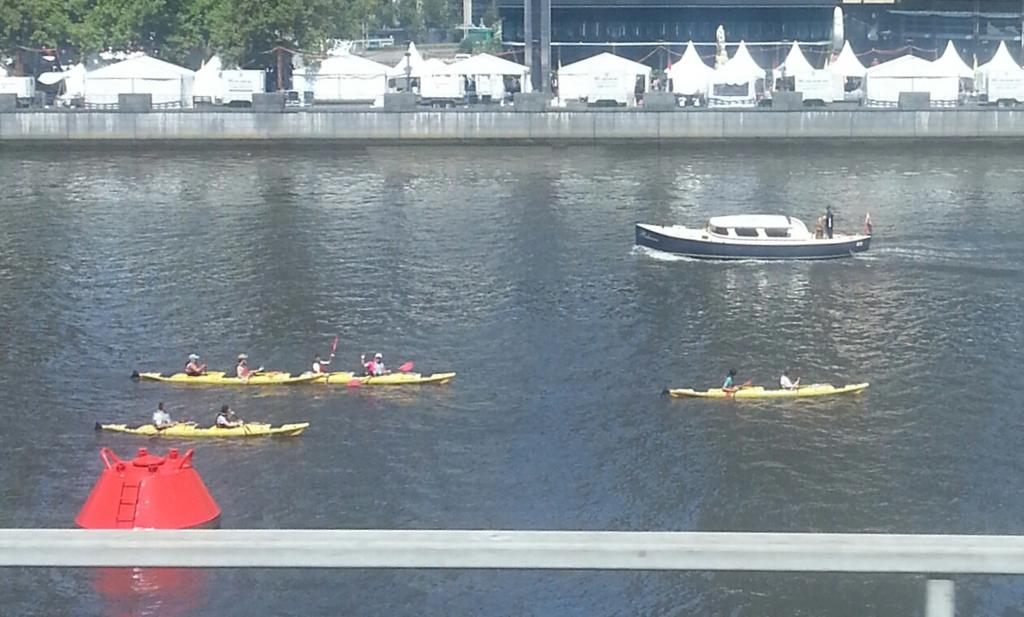What is the primary element visible in the image? There is water in the image. What are the people doing in the image? The people are on boats in the image. What structures can be seen in the image? There are buildings in the image. What type of vegetation is present in the image? There are trees in the image. What year is depicted in the image? The provided facts do not mention a specific year, so it cannot be determined from the image. How does the snow affect the people on the boats in the image? There is no snow present in the image, so it does not affect the people on the boats. 